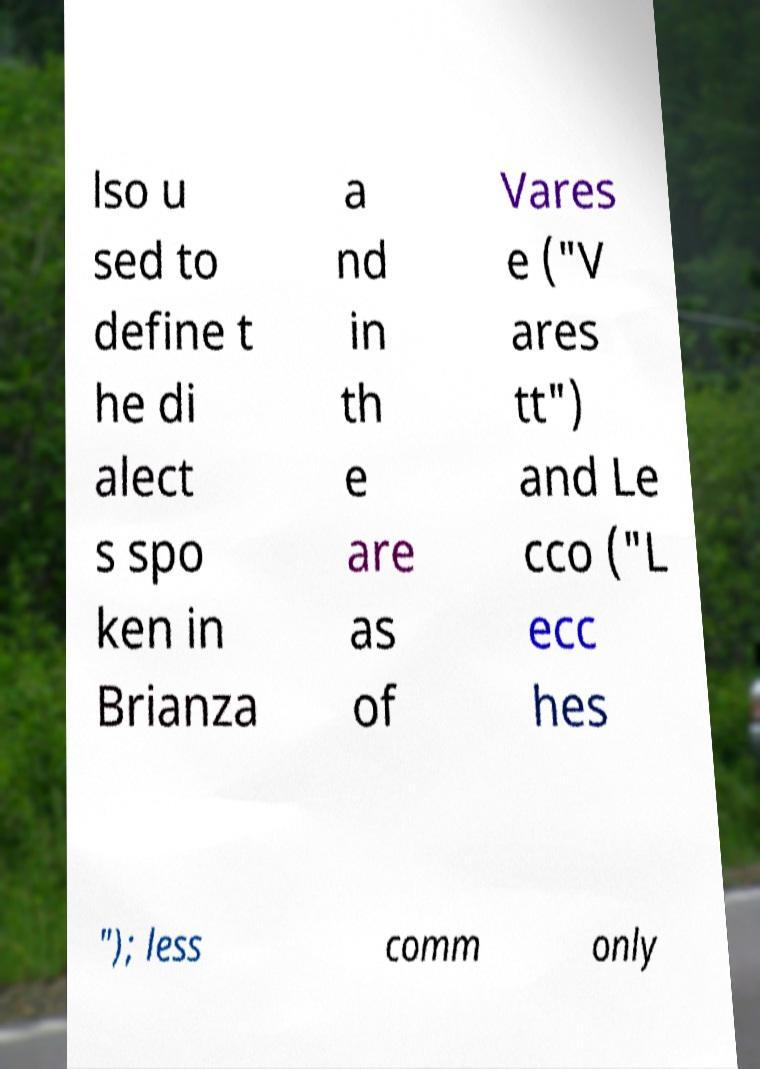For documentation purposes, I need the text within this image transcribed. Could you provide that? lso u sed to define t he di alect s spo ken in Brianza a nd in th e are as of Vares e ("V ares tt") and Le cco ("L ecc hes "); less comm only 